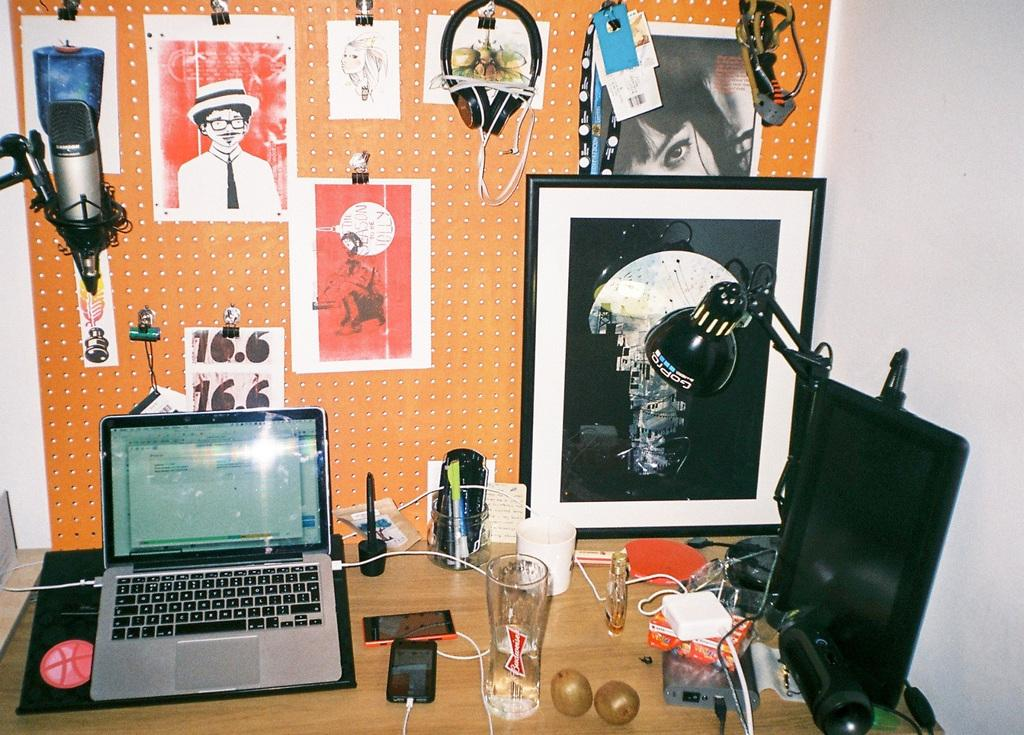What is present on the table in the image? There are objects on the table in the image. Can you describe what is on the wall in the background of the image? There are depictions on the wall in the background of the image. Where is the father sitting in the image? There is no father present in the image. What type of sand can be seen on the floor in the image? There is no sand present in the image. 